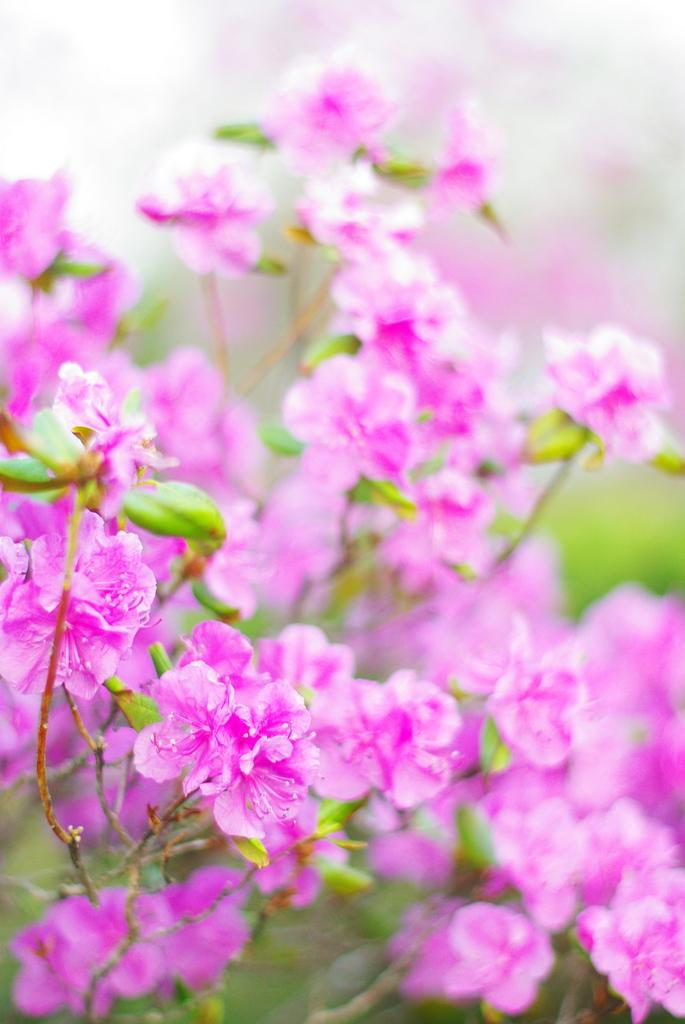What type of flowers are present in the image? There are pink flowers in the image. Can you describe the background of the image? The background of the image is blurred. How many waves can be seen in the image? There are no waves present in the image; it features pink flowers and a blurred background. What type of yard is visible in the image? There is no yard visible in the image; it only shows pink flowers and a blurred background. 